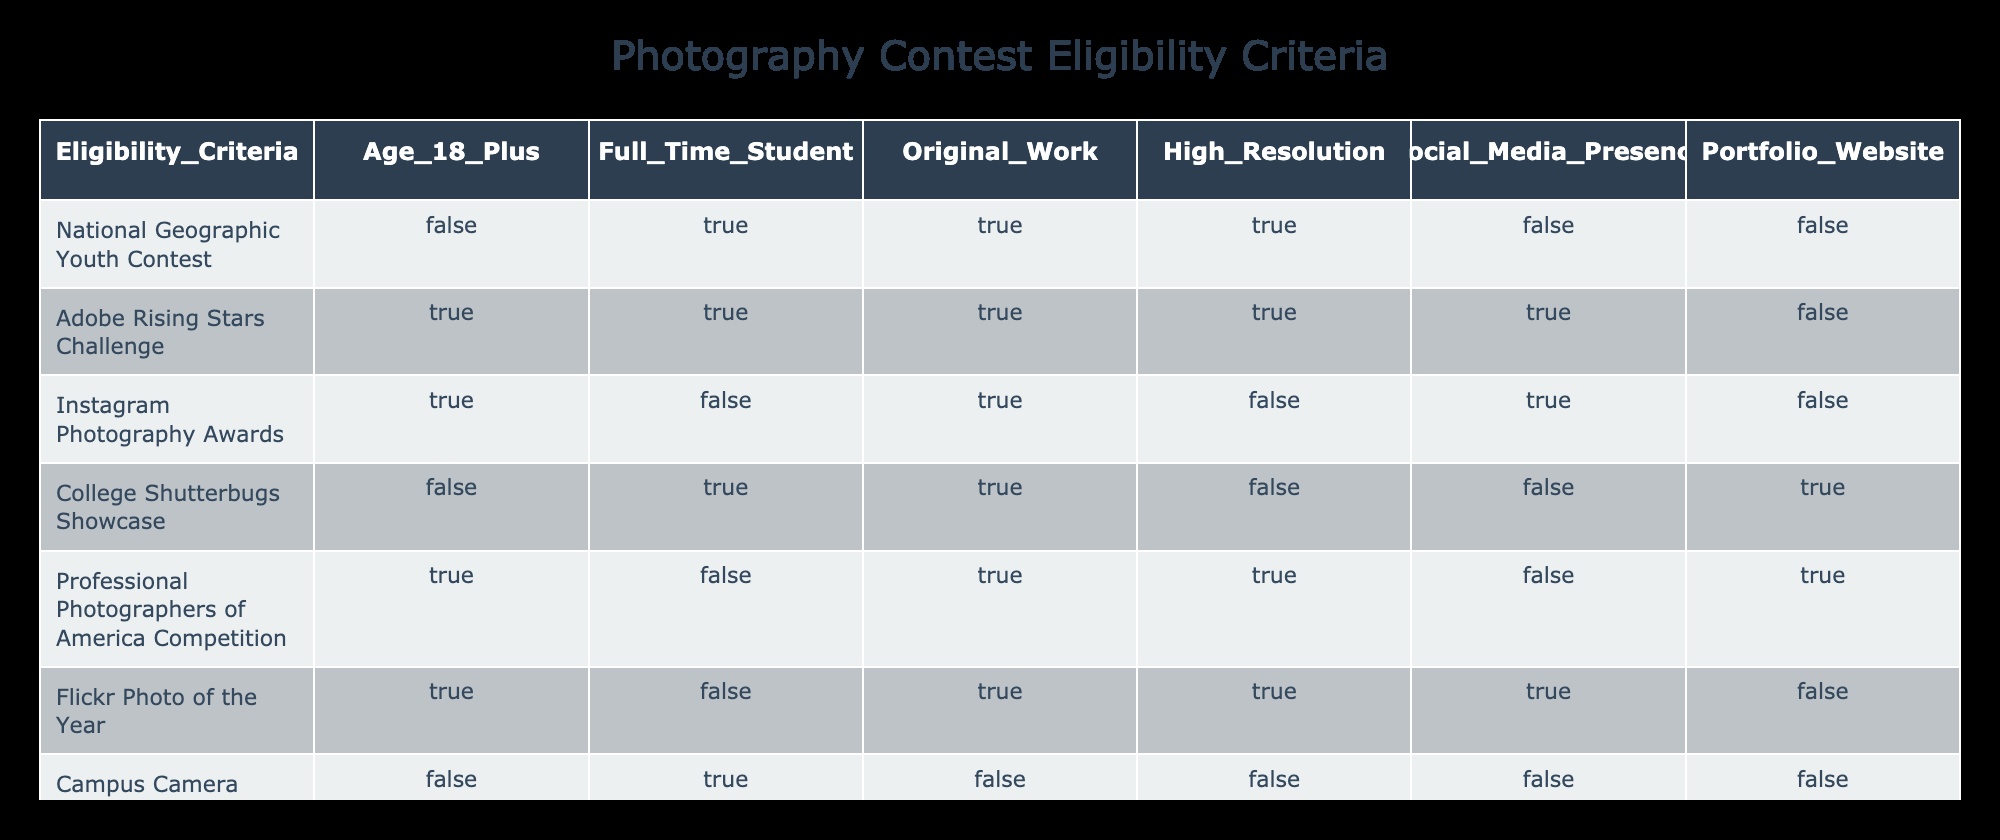What contests allow for entries from individuals who are not 18? By examining the table, we look for rows where the "Age 18 Plus" column is marked as FALSE. Both the "College Shutterbugs Showcase" and the "Campus Camera Club Exhibition" are listed as allowing entries from individuals who are not 18.
Answer: College Shutterbugs Showcase, Campus Camera Club Exhibition Which contests require social media presence? We will check the "Social Media Presence" column for TRUE values. The contests "Adobe Rising Stars Challenge," "Instagram Photography Awards," and "Flickr Photo of the Year" all have a TRUE value in this column indicating that they require social media presence.
Answer: Adobe Rising Stars Challenge, Instagram Photography Awards, Flickr Photo of the Year How many contests require original work? To determine this, we need to count all the rows where the "Original Work" column is TRUE. By checking the table, we find that there are six contests that require original work: "National Geographic Youth Contest," "Adobe Rising Stars Challenge," "Instagram Photography Awards," "College Shutterbugs Showcase," "Professional Photographers of America Competition," and "Sony World Photography Awards - Student Focus."
Answer: 6 Is the "Sony World Photography Awards - Student Focus" open to full-time students? We check the corresponding row for "Sony World Photography Awards - Student Focus" and see that the "Full Time Student" column is marked TRUE, indicating that it is indeed open to full-time students.
Answer: Yes Which contest has the highest requirements with both high resolution and original work? To find the contest with the highest requirements in both categories, check the rows where both "High Resolution" and "Original Work" are TRUE. The contests "Adobe Rising Stars Challenge," "Professional Photographers of America Competition," and "Flickr Photo of the Year" meet this criterion as they have both marked as TRUE.
Answer: Adobe Rising Stars Challenge, Professional Photographers of America Competition, Flickr Photo of the Year How many contests are available for students who do not have a portfolio website? Look for rows where the "Portfolio Website" column is marked as FALSE. These contests are "National Geographic Youth Contest," "Adobe Rising Stars Challenge," "Instagram Photography Awards," "College Shutterbugs Showcase," and "Flickr Photo of the Year," which totals five contests available for students without a portfolio website.
Answer: 5 Are there any contests that require both high resolution and have no age requirement (age 18 plus)? We inspect the rows where "High Resolution" is TRUE and "Age 18 Plus" is FALSE. The "College Shutterbugs Showcase" fits this requirement since it requires high resolution but does not have an age constraint.
Answer: Yes, College Shutterbugs Showcase How many contests are there in total that allow entries from full-time students? We need to count all the rows that have TRUE in the "Full Time Student" column. A total of five contests allow entries from full-time students: "Adobe Rising Stars Challenge," "College Shutterbugs Showcase," "Professional Photographers of America Competition," "Sony World Photography Awards - Student Focus," and "Campus Camera Club Exhibition."
Answer: 5 